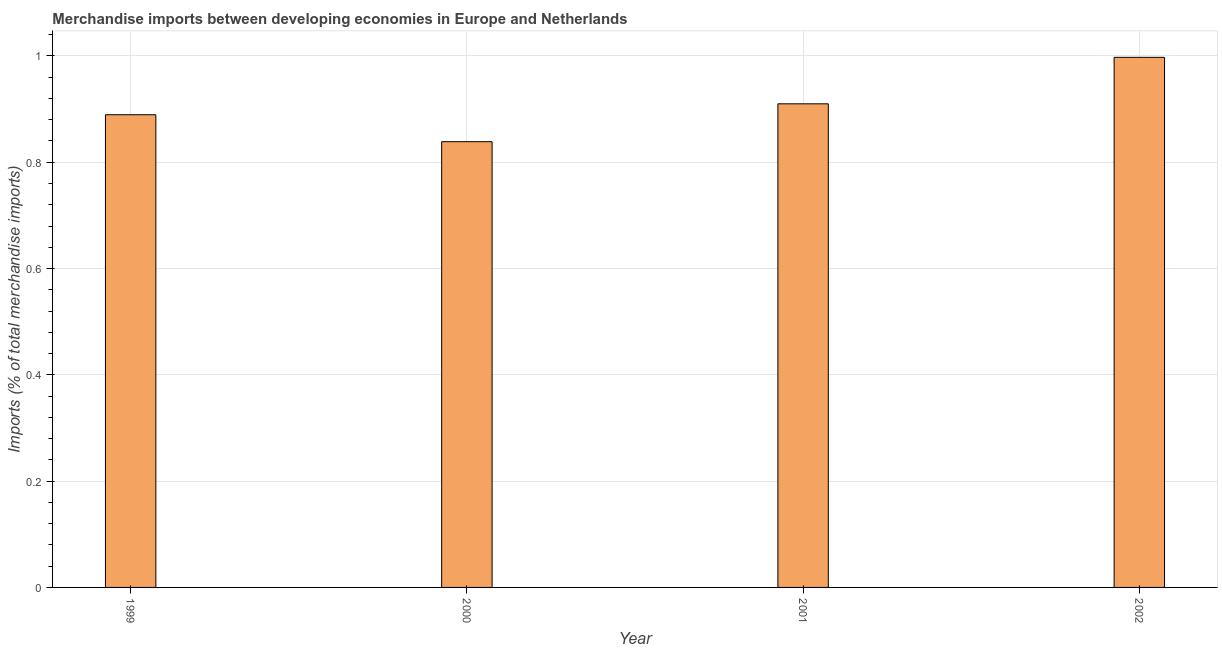Does the graph contain any zero values?
Keep it short and to the point. No. What is the title of the graph?
Your response must be concise. Merchandise imports between developing economies in Europe and Netherlands. What is the label or title of the X-axis?
Keep it short and to the point. Year. What is the label or title of the Y-axis?
Your answer should be compact. Imports (% of total merchandise imports). What is the merchandise imports in 2000?
Your answer should be compact. 0.84. Across all years, what is the maximum merchandise imports?
Your response must be concise. 1. Across all years, what is the minimum merchandise imports?
Keep it short and to the point. 0.84. In which year was the merchandise imports maximum?
Provide a short and direct response. 2002. In which year was the merchandise imports minimum?
Offer a terse response. 2000. What is the sum of the merchandise imports?
Ensure brevity in your answer.  3.64. What is the difference between the merchandise imports in 2000 and 2001?
Give a very brief answer. -0.07. What is the average merchandise imports per year?
Ensure brevity in your answer.  0.91. What is the median merchandise imports?
Keep it short and to the point. 0.9. What is the ratio of the merchandise imports in 2001 to that in 2002?
Offer a terse response. 0.91. Is the merchandise imports in 1999 less than that in 2002?
Provide a succinct answer. Yes. What is the difference between the highest and the second highest merchandise imports?
Ensure brevity in your answer.  0.09. Is the sum of the merchandise imports in 2001 and 2002 greater than the maximum merchandise imports across all years?
Offer a terse response. Yes. What is the difference between the highest and the lowest merchandise imports?
Keep it short and to the point. 0.16. In how many years, is the merchandise imports greater than the average merchandise imports taken over all years?
Offer a very short reply. 2. How many bars are there?
Your answer should be compact. 4. Are all the bars in the graph horizontal?
Provide a short and direct response. No. How many years are there in the graph?
Offer a very short reply. 4. Are the values on the major ticks of Y-axis written in scientific E-notation?
Offer a very short reply. No. What is the Imports (% of total merchandise imports) of 1999?
Make the answer very short. 0.89. What is the Imports (% of total merchandise imports) of 2000?
Your answer should be compact. 0.84. What is the Imports (% of total merchandise imports) of 2001?
Your answer should be compact. 0.91. What is the Imports (% of total merchandise imports) in 2002?
Your answer should be very brief. 1. What is the difference between the Imports (% of total merchandise imports) in 1999 and 2000?
Your answer should be very brief. 0.05. What is the difference between the Imports (% of total merchandise imports) in 1999 and 2001?
Your response must be concise. -0.02. What is the difference between the Imports (% of total merchandise imports) in 1999 and 2002?
Offer a terse response. -0.11. What is the difference between the Imports (% of total merchandise imports) in 2000 and 2001?
Ensure brevity in your answer.  -0.07. What is the difference between the Imports (% of total merchandise imports) in 2000 and 2002?
Provide a short and direct response. -0.16. What is the difference between the Imports (% of total merchandise imports) in 2001 and 2002?
Offer a terse response. -0.09. What is the ratio of the Imports (% of total merchandise imports) in 1999 to that in 2000?
Keep it short and to the point. 1.06. What is the ratio of the Imports (% of total merchandise imports) in 1999 to that in 2001?
Offer a terse response. 0.98. What is the ratio of the Imports (% of total merchandise imports) in 1999 to that in 2002?
Offer a very short reply. 0.89. What is the ratio of the Imports (% of total merchandise imports) in 2000 to that in 2001?
Provide a succinct answer. 0.92. What is the ratio of the Imports (% of total merchandise imports) in 2000 to that in 2002?
Offer a terse response. 0.84. What is the ratio of the Imports (% of total merchandise imports) in 2001 to that in 2002?
Provide a succinct answer. 0.91. 